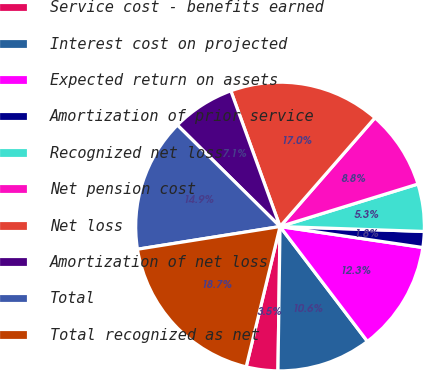Convert chart to OTSL. <chart><loc_0><loc_0><loc_500><loc_500><pie_chart><fcel>Service cost - benefits earned<fcel>Interest cost on projected<fcel>Expected return on assets<fcel>Amortization of prior service<fcel>Recognized net loss<fcel>Net pension cost<fcel>Net loss<fcel>Amortization of net loss<fcel>Total<fcel>Total recognized as net<nl><fcel>3.54%<fcel>10.58%<fcel>12.33%<fcel>1.78%<fcel>5.3%<fcel>8.82%<fcel>16.96%<fcel>7.06%<fcel>14.92%<fcel>18.72%<nl></chart> 